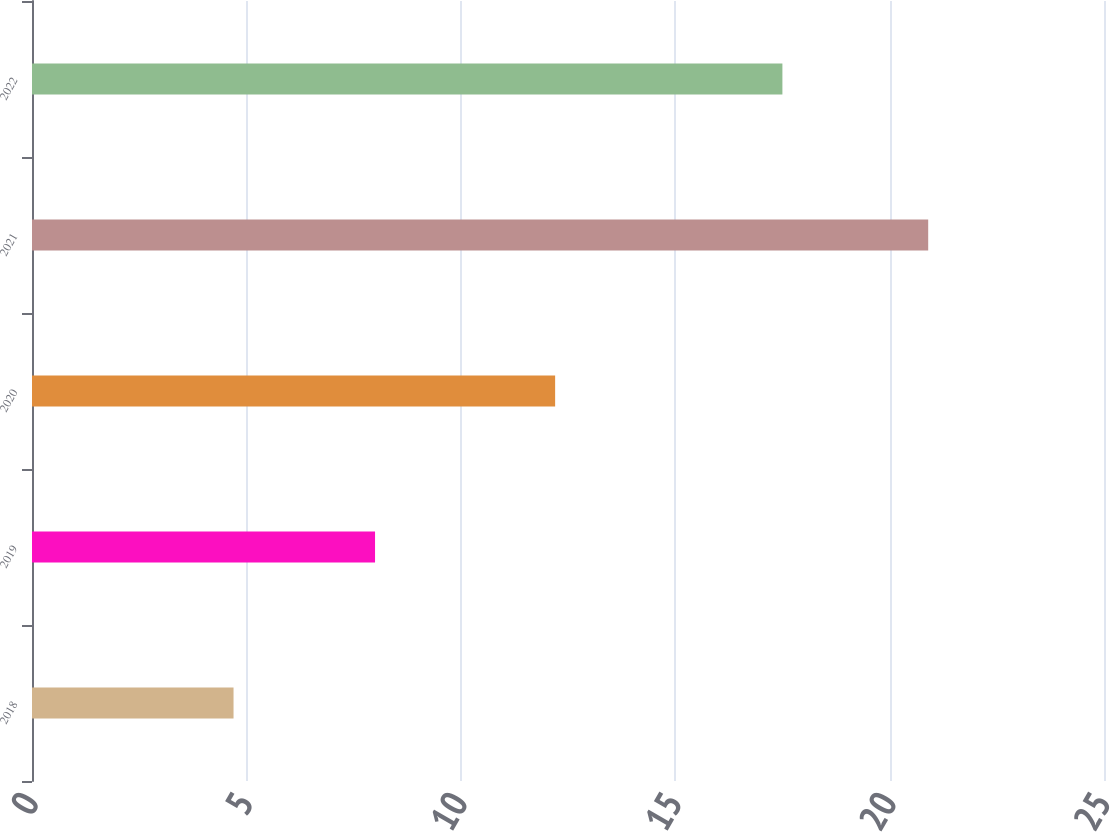Convert chart. <chart><loc_0><loc_0><loc_500><loc_500><bar_chart><fcel>2018<fcel>2019<fcel>2020<fcel>2021<fcel>2022<nl><fcel>4.7<fcel>8<fcel>12.2<fcel>20.9<fcel>17.5<nl></chart> 